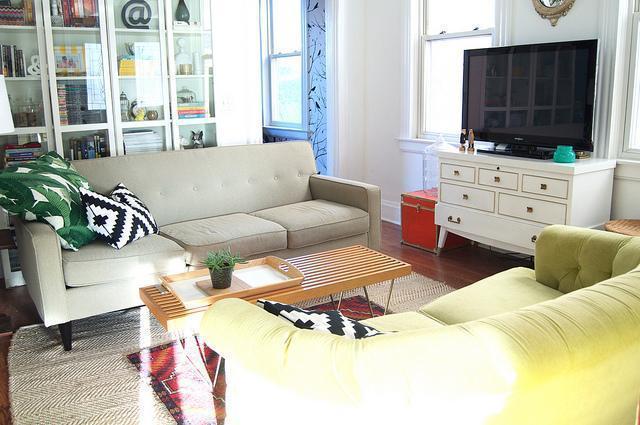What color is the vase on the right side of the white entertainment center?
Choose the right answer from the provided options to respond to the question.
Options: Turquoise, yellow, red, red. Turquoise. 